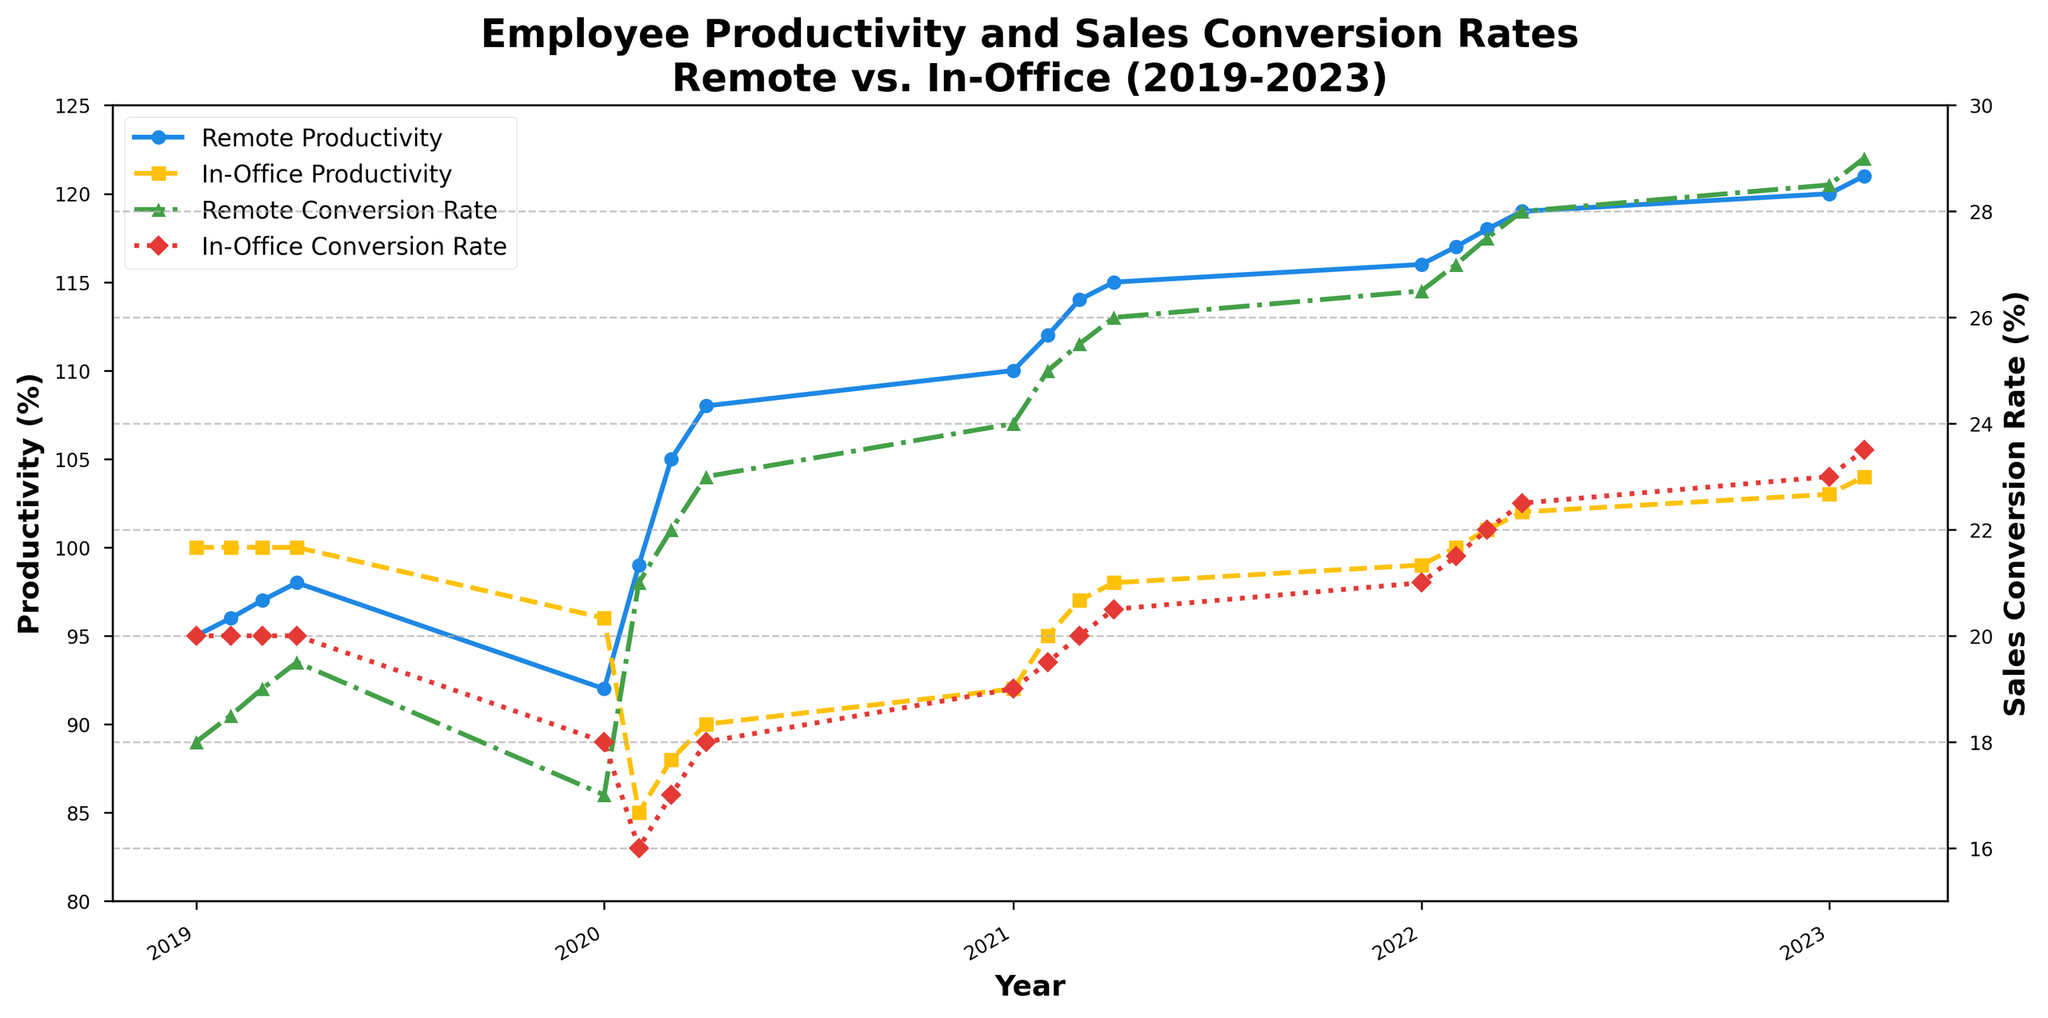what was the highest remote productivity percentage recorded? The highest remote productivity percentage can be determined by looking at the peak value of the "Remote Productivity (%)" line. The point on the chart with the highest value for this measure is 121% in Q2 2023.
Answer: 121% how did the remote productivity percentages change from Q4 2019 to Q2 2020? To find the change in remote productivity percentages from Q4 2019 to Q2 2020, look at the values at these two points in time. The value was 98% in Q4 2019 and 99% in Q2 2020. So, the change is 99% - 98% = 1%.
Answer: increased by 1% was there any quarter where in-office sales conversion rate was equal to the remote sales conversion rate? Reviewing the chart, it's observable that the lines for "In-Office Sales Conversion Rate (%)" and "Remote Sales Conversion Rate (%)" never intersect. Therefore, there is no quarter where these rates are equal.
Answer: No what is the average remote productivity percentage in 2021? To calculate the average remote productivity percentage for the year 2021, average the four quarterly values: (110% + 112% + 114% + 115%) / 4 = 113.
Answer: 113% what is the difference between remote and in-office productivity percentages in Q2 2020? The remote productivity percentage in Q2 2020 is 99%, and the in-office productivity percentage is 85%. The difference is 99% - 85% = 14%.
Answer: 14% which year showed the highest increase in remote productivity percentages? Comparing the yearly increase, we see the following changes: 2019 to 2020 (98% to 99%), 2020 to 2021 (99% to 115%), 2021 to 2022 (115% to 119%), and 2022 to 2023 (119% to 121%). The highest increase occurred from 2020 to 2021 (16%).
Answer: 2020 to 2021 how do the trends of remote and in-office productivity compare from 2020 Q1 to 2023 Q2? Reviewing the periods from 2020 Q1 to 2023 Q2 illustrates divergent trends: remote productivity shows a consistent upward trajectory from 92% to 121%, while in-office productivity drops initially (96% to 85%) but recovers gradually back to 104%.
Answer: remote increased, in-office declined then recovered in which quarter did remote sales conversion rate surpass in-office rates the most? The widest gap can be found by comparing the green and red lines, which is most noticeable in Q2 2020, where remote is at 21% and in-office is at 16%. The difference is 21% - 16% = 5%.
Answer: Q2 2020 what was the lowest in-office productivity percentage observed? The lowest percentage is seen at the dip in Q2 2020, marked at 85%.
Answer: 85% 